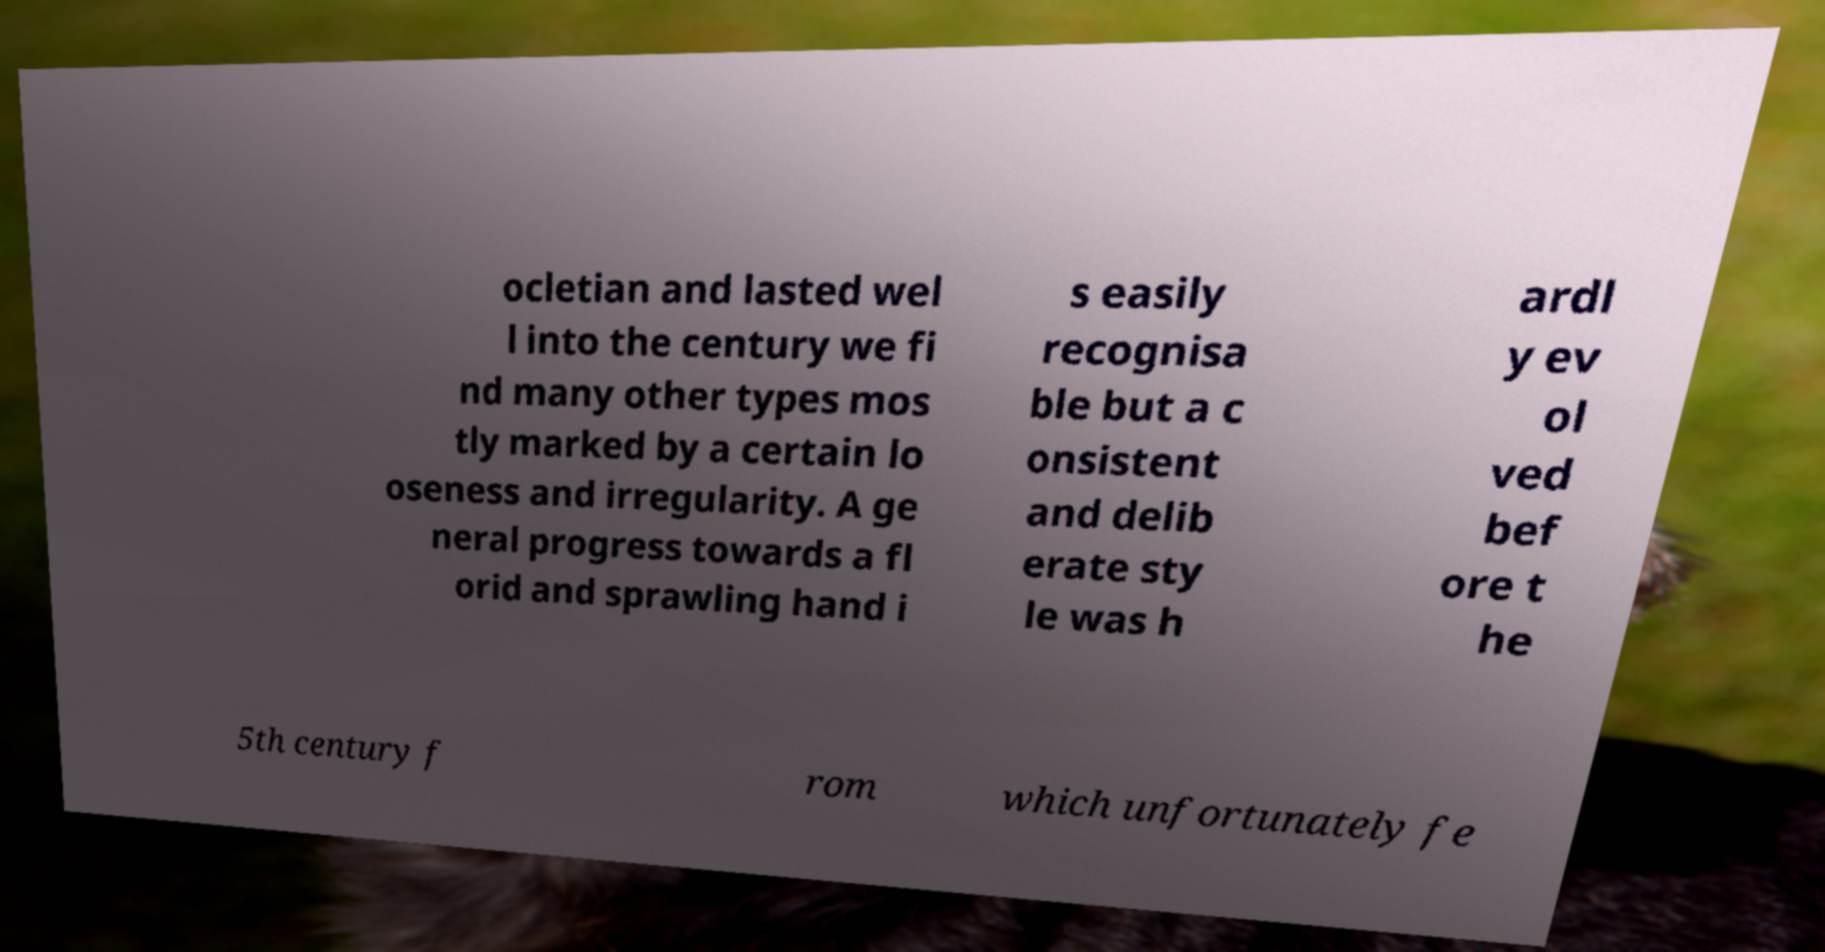There's text embedded in this image that I need extracted. Can you transcribe it verbatim? ocletian and lasted wel l into the century we fi nd many other types mos tly marked by a certain lo oseness and irregularity. A ge neral progress towards a fl orid and sprawling hand i s easily recognisa ble but a c onsistent and delib erate sty le was h ardl y ev ol ved bef ore t he 5th century f rom which unfortunately fe 